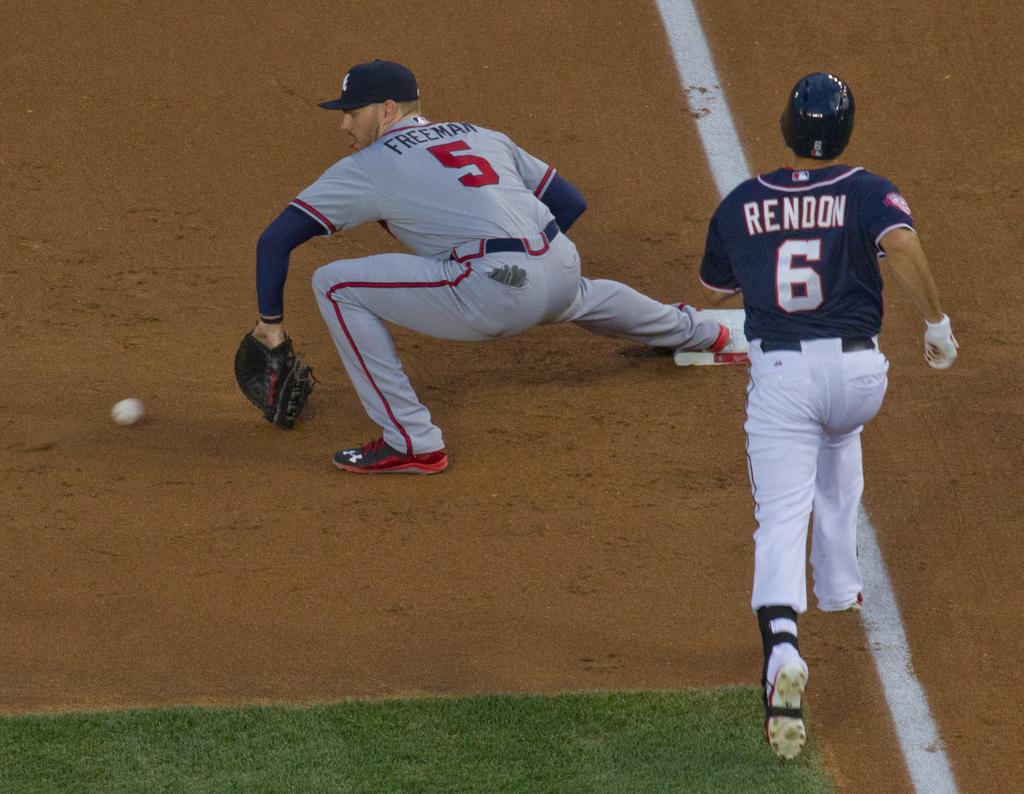What number is the player that is wearing the blue jersey?
Offer a very short reply. 6. Who's playing first base?
Your response must be concise. Freeman. 